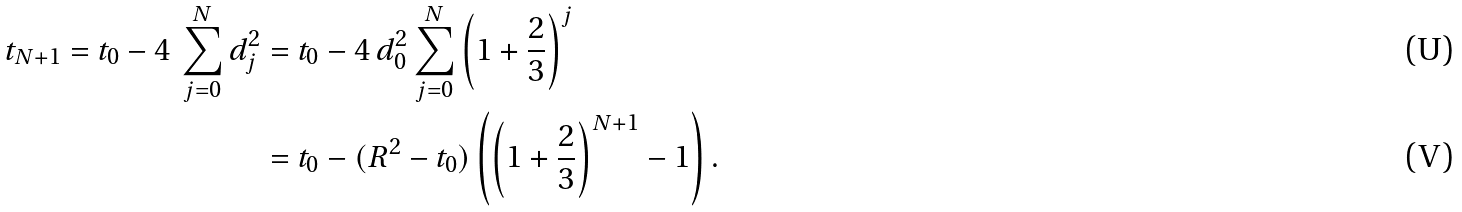Convert formula to latex. <formula><loc_0><loc_0><loc_500><loc_500>t _ { N + 1 } = t _ { 0 } - 4 \, \sum _ { j = 0 } ^ { N } d _ { j } ^ { 2 } & = t _ { 0 } - 4 \, d _ { 0 } ^ { 2 } \sum _ { j = 0 } ^ { N } \left ( 1 + \frac { 2 } { 3 } \right ) ^ { j } \\ & = t _ { 0 } - ( R ^ { 2 } - t _ { 0 } ) \left ( \left ( 1 + \frac { 2 } { 3 } \right ) ^ { N + 1 } - 1 \right ) .</formula> 